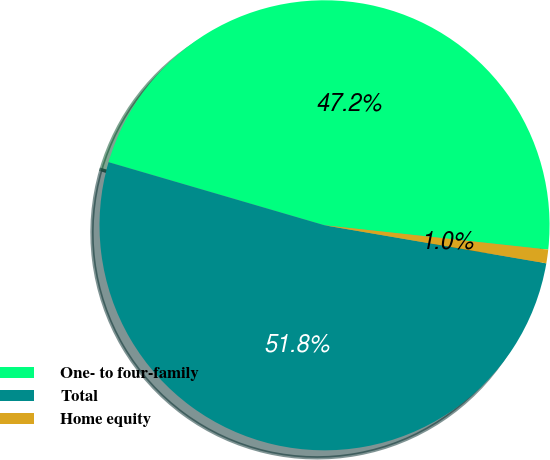Convert chart. <chart><loc_0><loc_0><loc_500><loc_500><pie_chart><fcel>One- to four-family<fcel>Total<fcel>Home equity<nl><fcel>47.2%<fcel>51.82%<fcel>0.98%<nl></chart> 